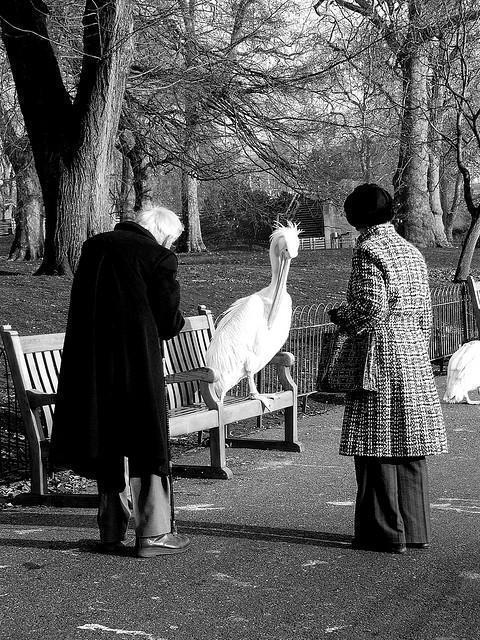What is the bird on the bench called?
Select the correct answer and articulate reasoning with the following format: 'Answer: answer
Rationale: rationale.'
Options: Hawk, flamingo, penguin, stork. Answer: stork.
Rationale: The bird on the bench is large and has a large beak for swallowing birds. 